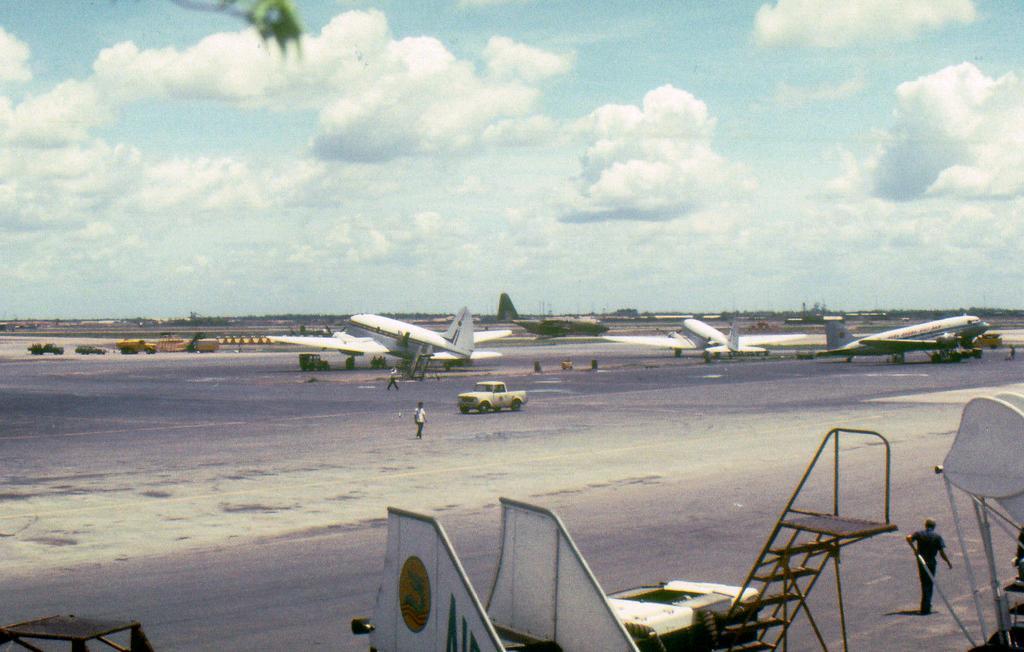Can you describe this image briefly? In the image we can see there are aeroplanes which are parked on the runway road and there are other vehicles standing beside the aeroplane. There are people standing on the runway road and in front there are stairs stand. 